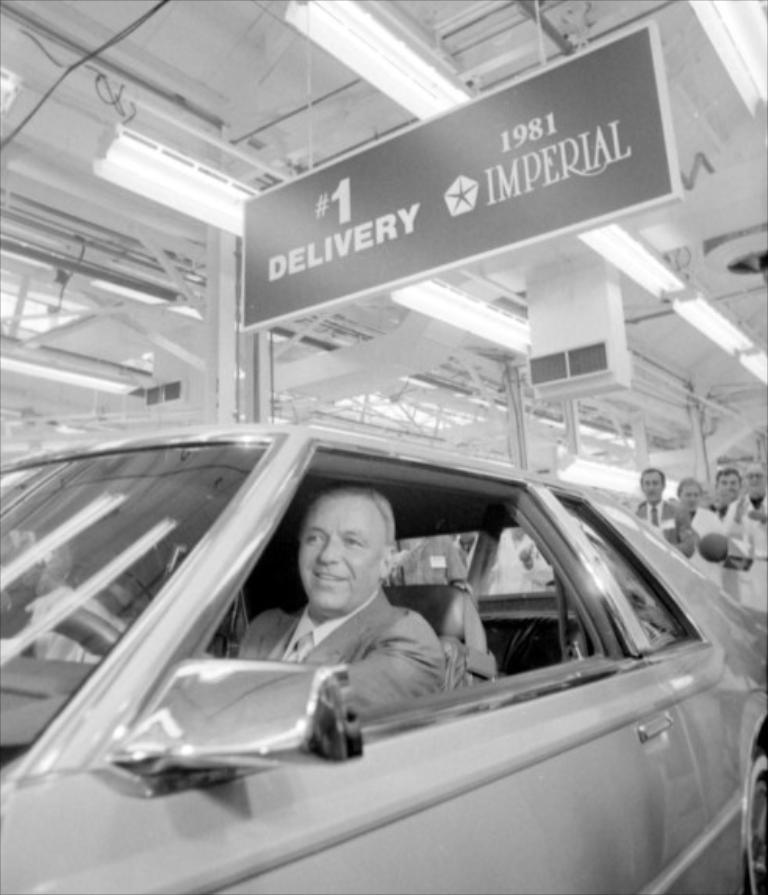Please provide a concise description of this image. In this picture there is a vehicle and person sitting inside vehicle and they are many other people behind vehicle 